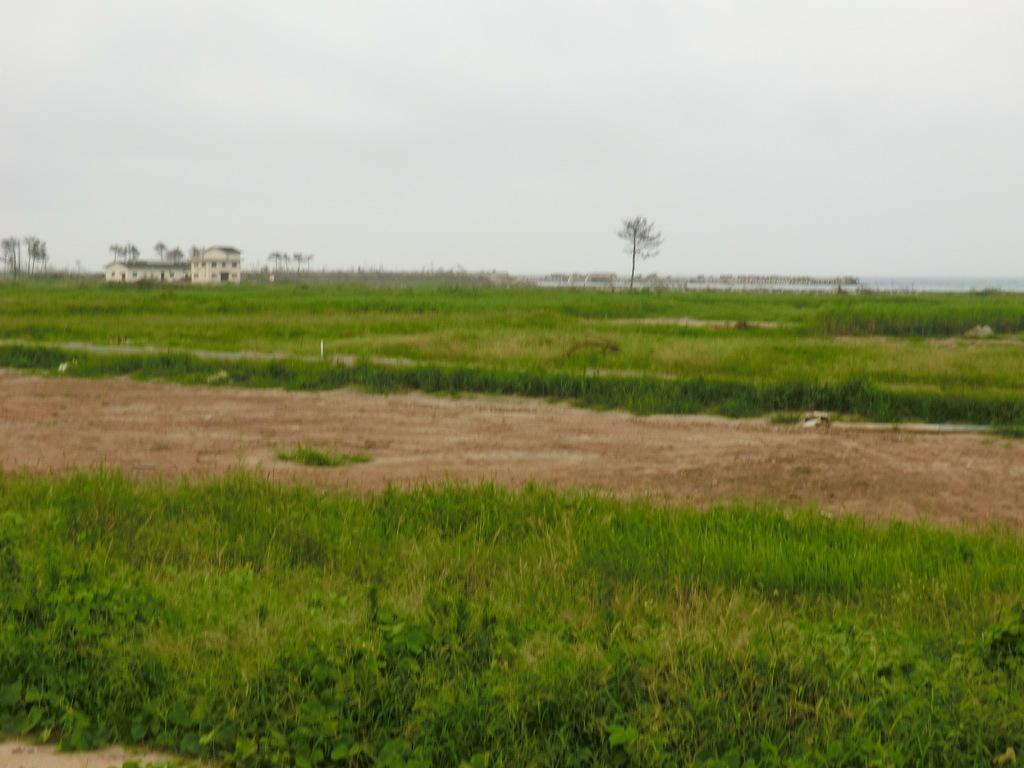In one or two sentences, can you explain what this image depicts? This image consists of many plants and grass. At the bottom, we can see the ground. In the background, there is a building. At the top, there is sky. 